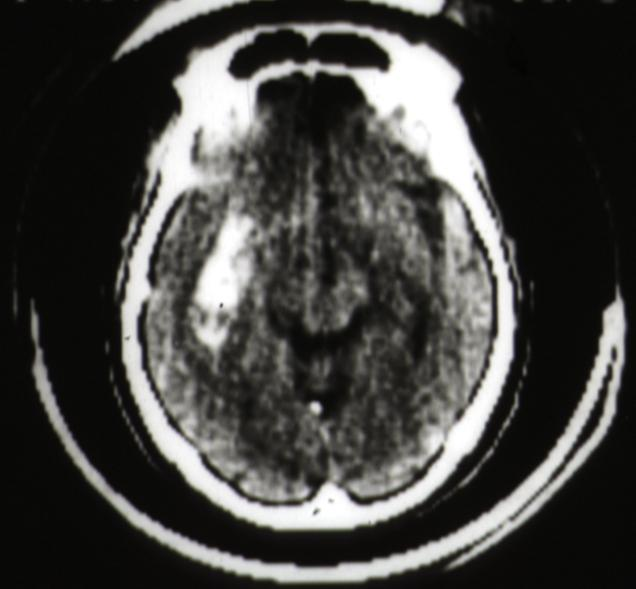what is present?
Answer the question using a single word or phrase. Brain 